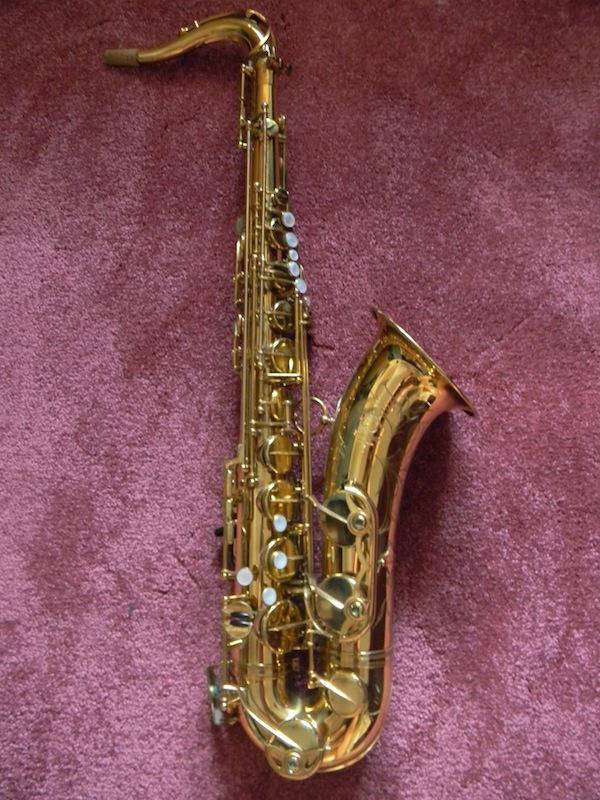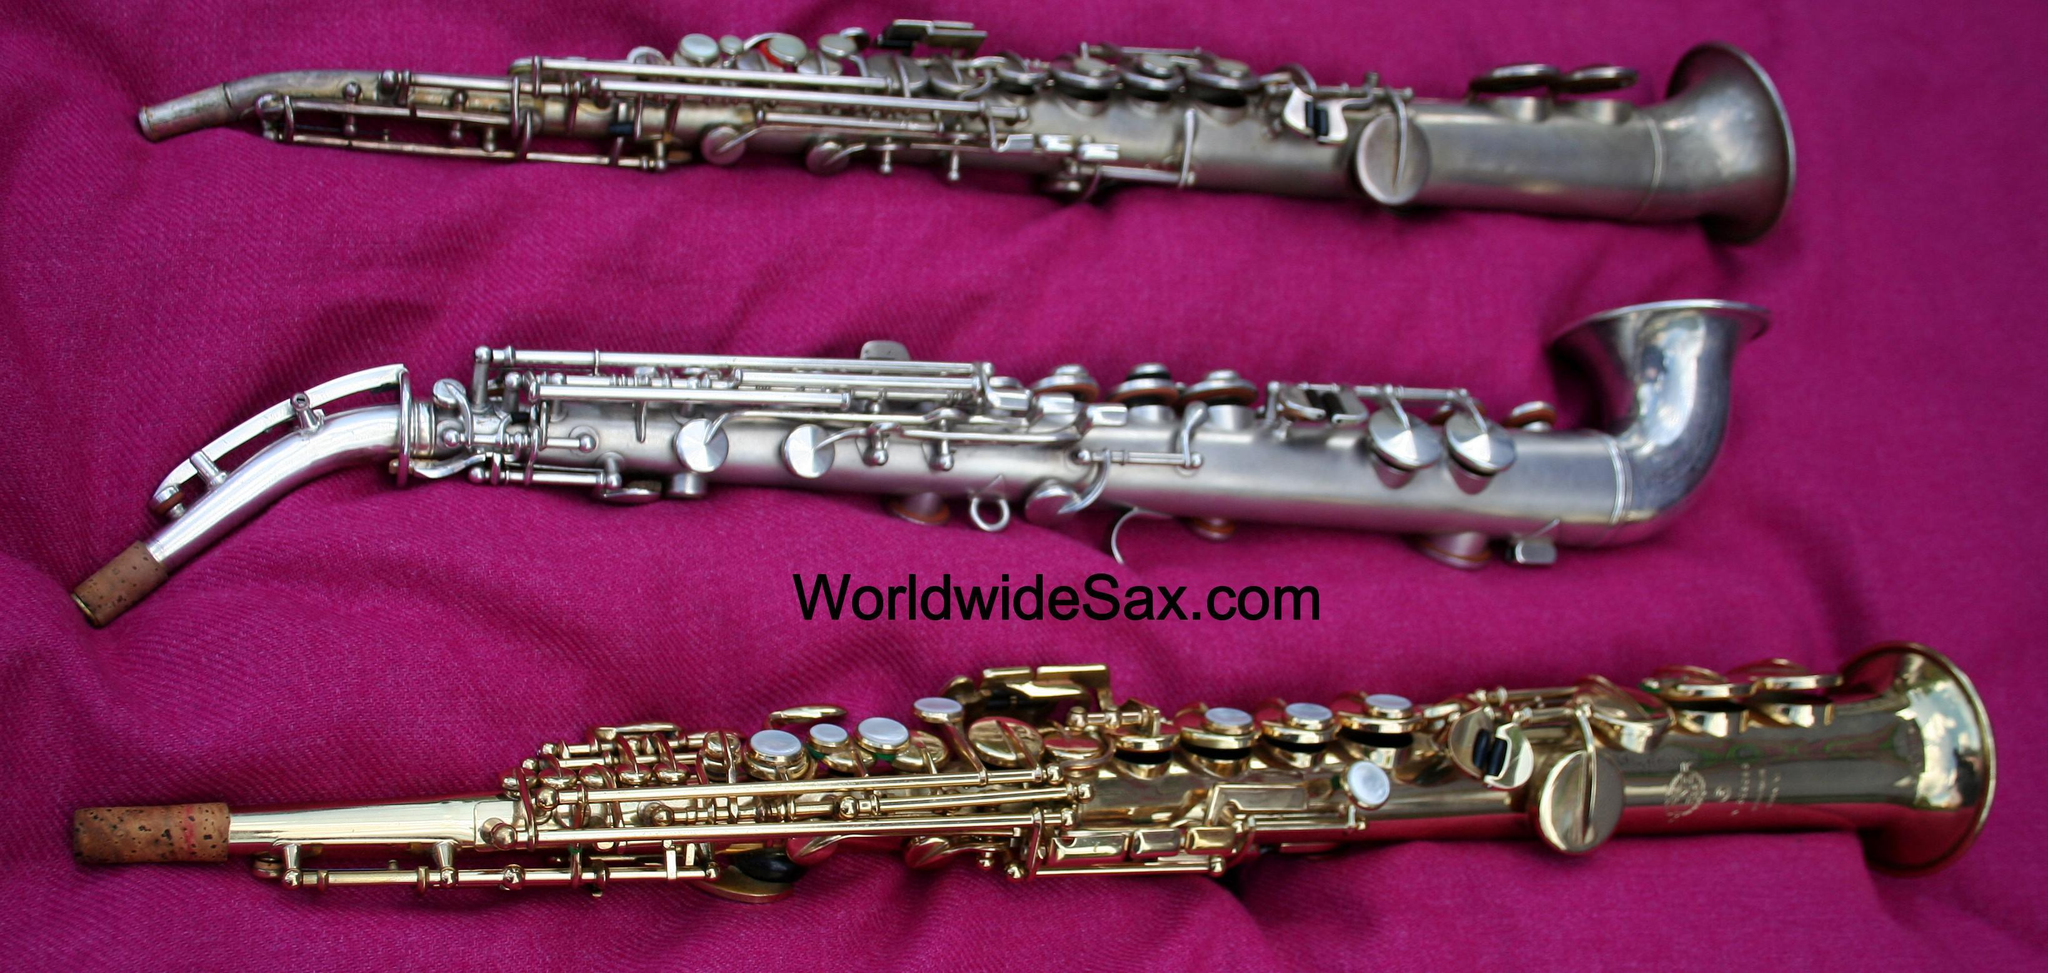The first image is the image on the left, the second image is the image on the right. Given the left and right images, does the statement "At least one image shows a straight instrument displayed next to a saxophone with a curved bell and mouthpiece." hold true? Answer yes or no. Yes. The first image is the image on the left, the second image is the image on the right. Considering the images on both sides, is "Has an image with more than one kind of saxophone." valid? Answer yes or no. Yes. 